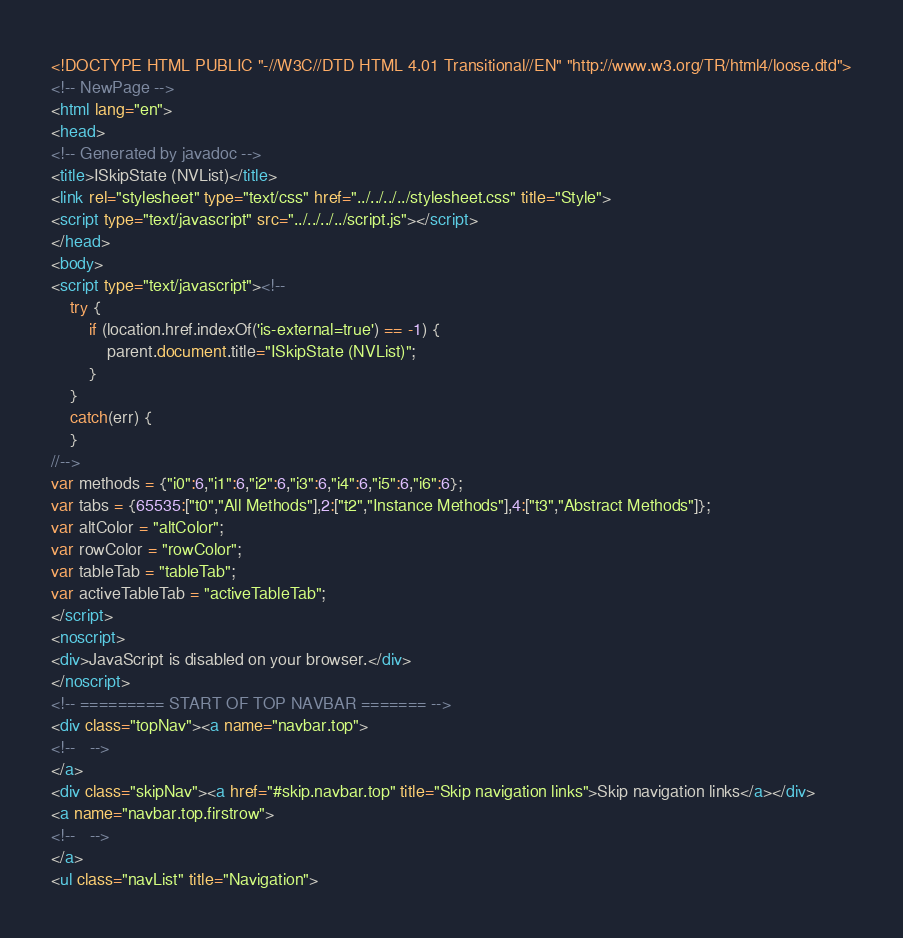Convert code to text. <code><loc_0><loc_0><loc_500><loc_500><_HTML_><!DOCTYPE HTML PUBLIC "-//W3C//DTD HTML 4.01 Transitional//EN" "http://www.w3.org/TR/html4/loose.dtd">
<!-- NewPage -->
<html lang="en">
<head>
<!-- Generated by javadoc -->
<title>ISkipState (NVList)</title>
<link rel="stylesheet" type="text/css" href="../../../../stylesheet.css" title="Style">
<script type="text/javascript" src="../../../../script.js"></script>
</head>
<body>
<script type="text/javascript"><!--
    try {
        if (location.href.indexOf('is-external=true') == -1) {
            parent.document.title="ISkipState (NVList)";
        }
    }
    catch(err) {
    }
//-->
var methods = {"i0":6,"i1":6,"i2":6,"i3":6,"i4":6,"i5":6,"i6":6};
var tabs = {65535:["t0","All Methods"],2:["t2","Instance Methods"],4:["t3","Abstract Methods"]};
var altColor = "altColor";
var rowColor = "rowColor";
var tableTab = "tableTab";
var activeTableTab = "activeTableTab";
</script>
<noscript>
<div>JavaScript is disabled on your browser.</div>
</noscript>
<!-- ========= START OF TOP NAVBAR ======= -->
<div class="topNav"><a name="navbar.top">
<!--   -->
</a>
<div class="skipNav"><a href="#skip.navbar.top" title="Skip navigation links">Skip navigation links</a></div>
<a name="navbar.top.firstrow">
<!--   -->
</a>
<ul class="navList" title="Navigation"></code> 